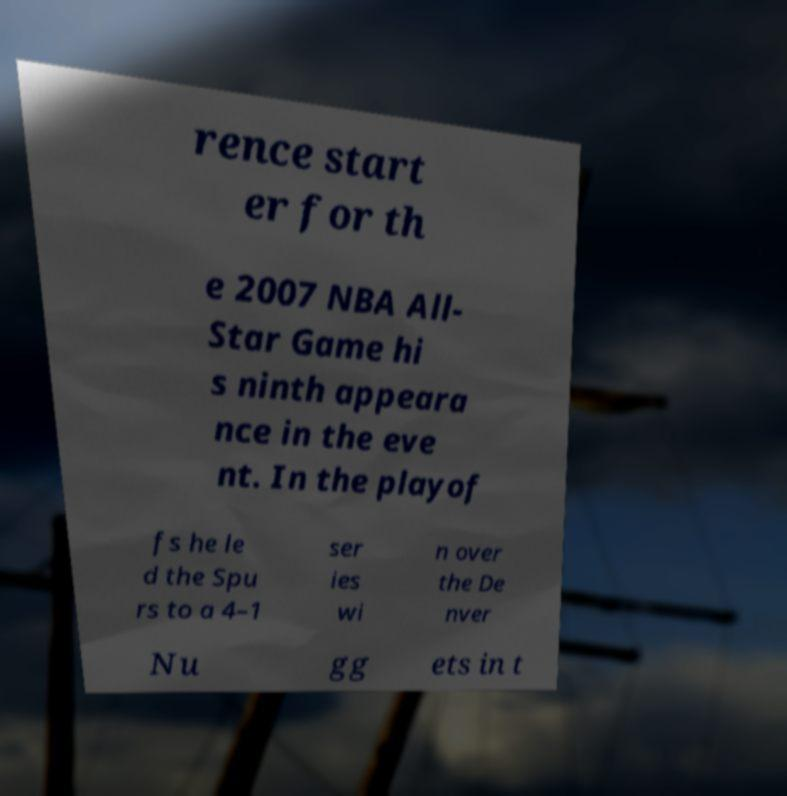Please read and relay the text visible in this image. What does it say? rence start er for th e 2007 NBA All- Star Game hi s ninth appeara nce in the eve nt. In the playof fs he le d the Spu rs to a 4–1 ser ies wi n over the De nver Nu gg ets in t 